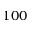Convert formula to latex. <formula><loc_0><loc_0><loc_500><loc_500>1 0 0</formula> 